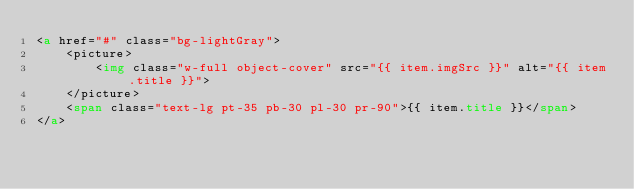<code> <loc_0><loc_0><loc_500><loc_500><_HTML_><a href="#" class="bg-lightGray">
    <picture>
        <img class="w-full object-cover" src="{{ item.imgSrc }}" alt="{{ item.title }}">
    </picture>
    <span class="text-lg pt-35 pb-30 pl-30 pr-90">{{ item.title }}</span>
</a>
</code> 